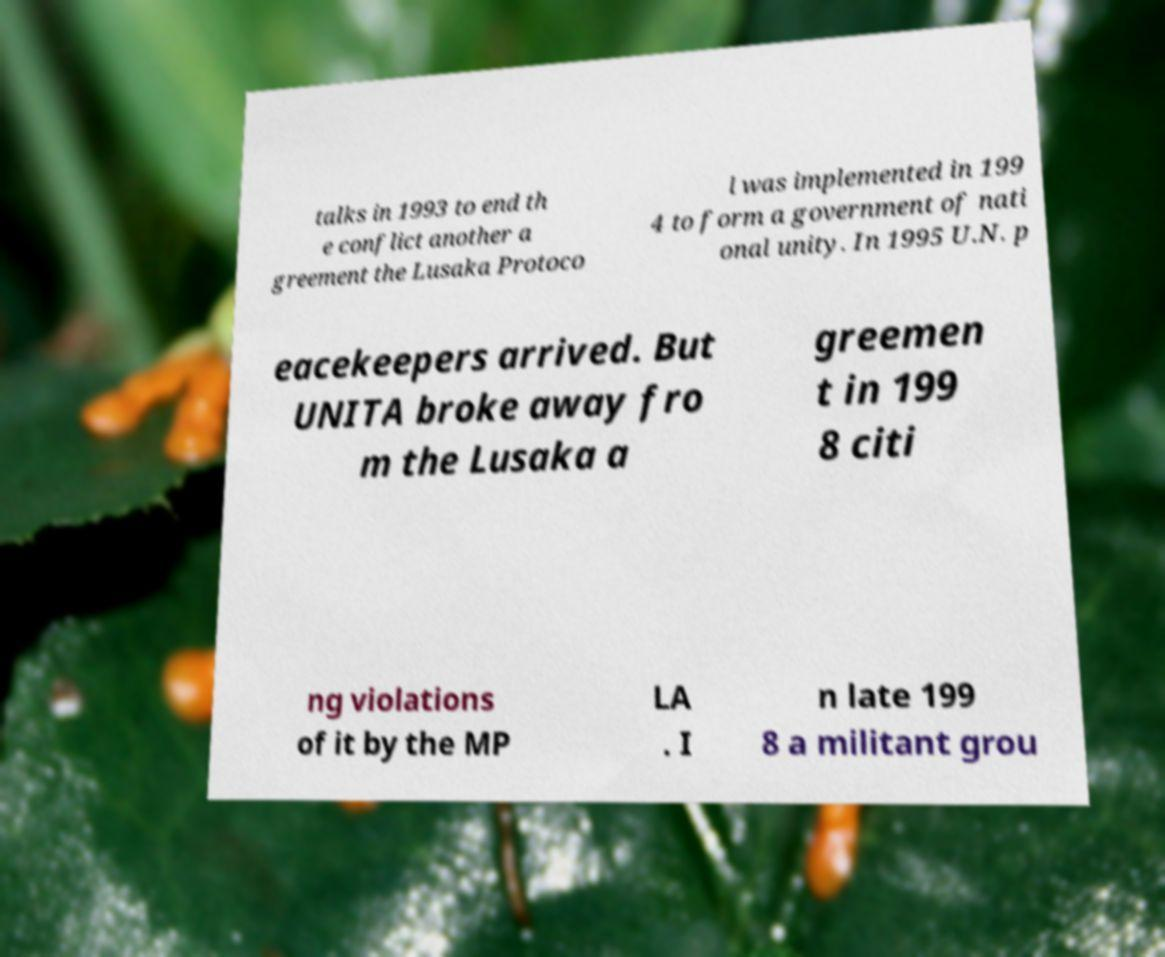Please identify and transcribe the text found in this image. talks in 1993 to end th e conflict another a greement the Lusaka Protoco l was implemented in 199 4 to form a government of nati onal unity. In 1995 U.N. p eacekeepers arrived. But UNITA broke away fro m the Lusaka a greemen t in 199 8 citi ng violations of it by the MP LA . I n late 199 8 a militant grou 